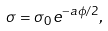Convert formula to latex. <formula><loc_0><loc_0><loc_500><loc_500>\sigma = \sigma _ { 0 } e ^ { - a \phi / 2 } ,</formula> 